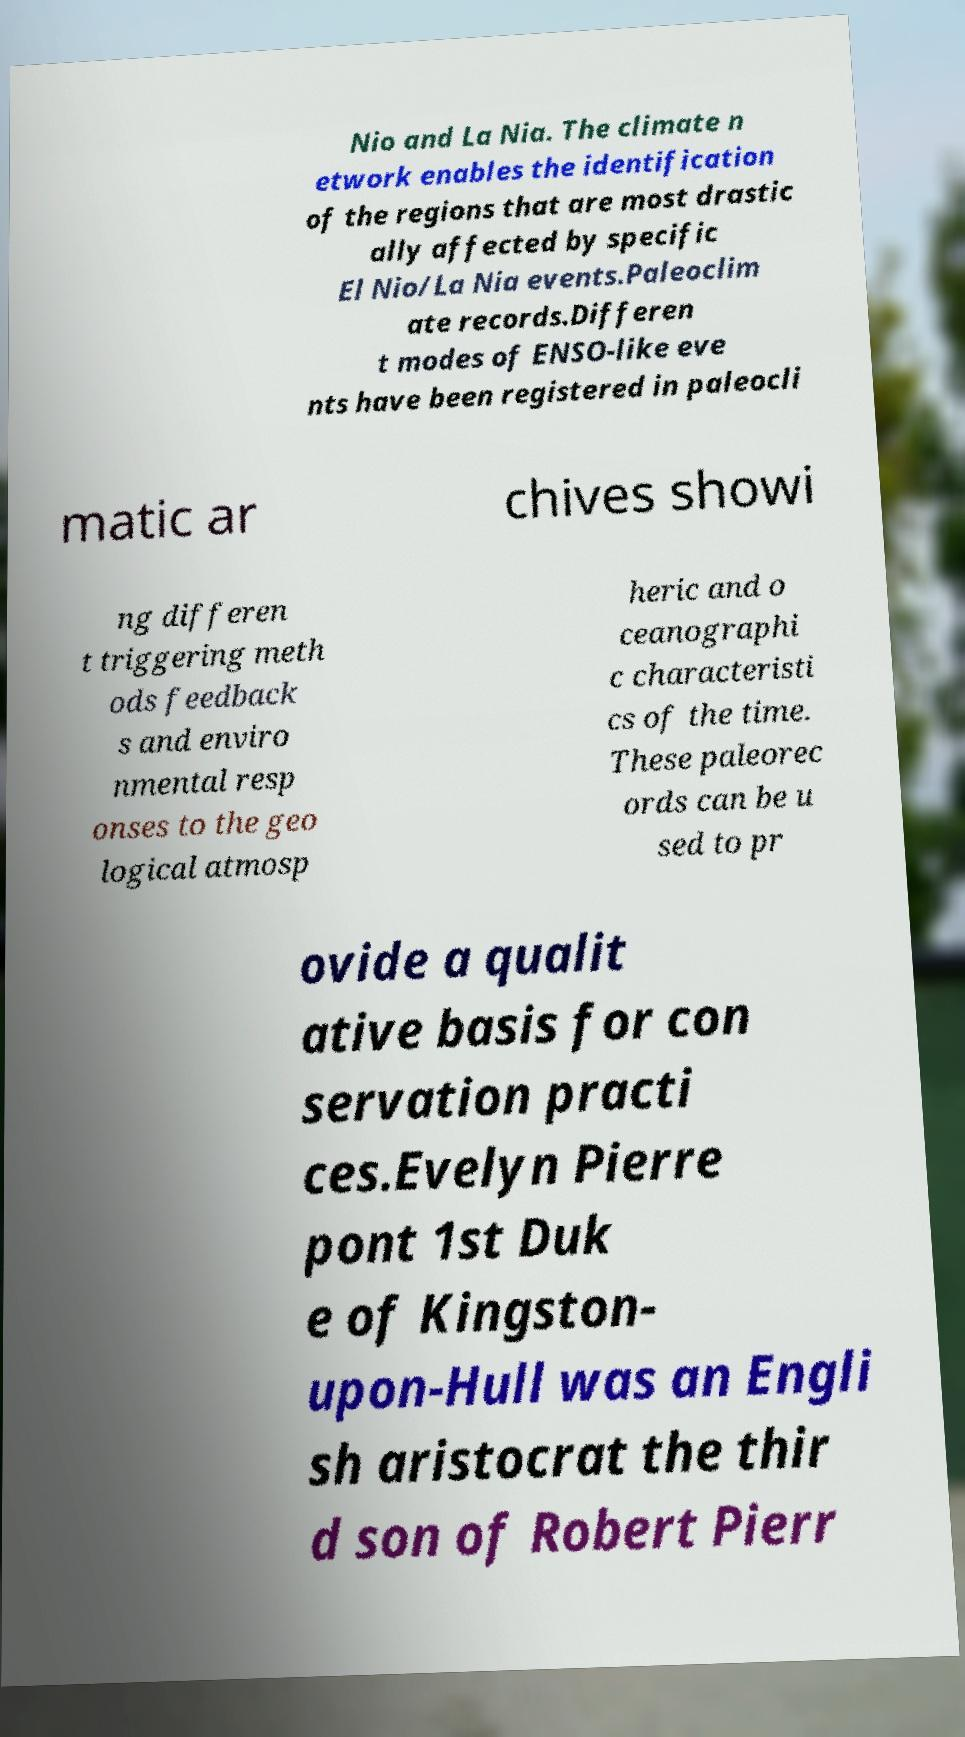Can you accurately transcribe the text from the provided image for me? Nio and La Nia. The climate n etwork enables the identification of the regions that are most drastic ally affected by specific El Nio/La Nia events.Paleoclim ate records.Differen t modes of ENSO-like eve nts have been registered in paleocli matic ar chives showi ng differen t triggering meth ods feedback s and enviro nmental resp onses to the geo logical atmosp heric and o ceanographi c characteristi cs of the time. These paleorec ords can be u sed to pr ovide a qualit ative basis for con servation practi ces.Evelyn Pierre pont 1st Duk e of Kingston- upon-Hull was an Engli sh aristocrat the thir d son of Robert Pierr 